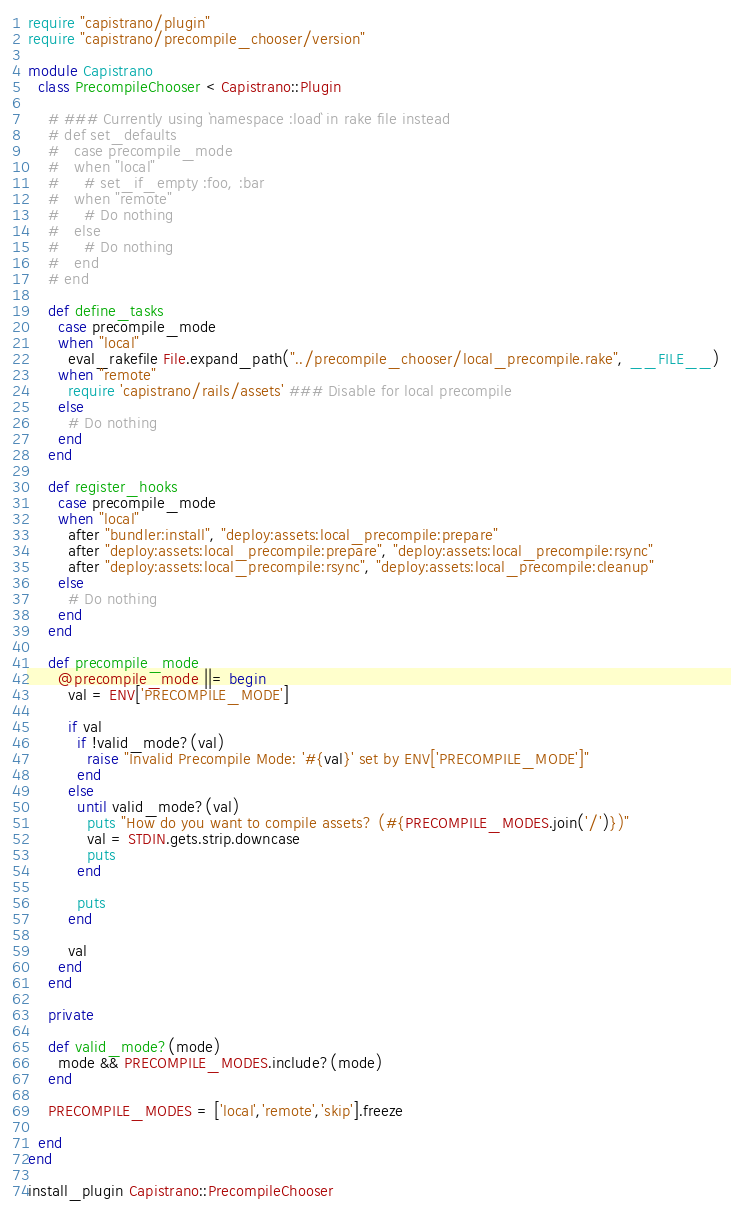Convert code to text. <code><loc_0><loc_0><loc_500><loc_500><_Ruby_>require "capistrano/plugin"
require "capistrano/precompile_chooser/version"

module Capistrano
  class PrecompileChooser < Capistrano::Plugin

    # ### Currently using `namespace :load` in rake file instead
    # def set_defaults
    #   case precompile_mode
    #   when "local"
    #     # set_if_empty :foo, :bar
    #   when "remote"
    #     # Do nothing
    #   else
    #     # Do nothing
    #   end
    # end

    def define_tasks
      case precompile_mode
      when "local"
        eval_rakefile File.expand_path("../precompile_chooser/local_precompile.rake", __FILE__)
      when "remote"
        require 'capistrano/rails/assets' ### Disable for local precompile
      else
        # Do nothing
      end
    end

    def register_hooks
      case precompile_mode
      when "local"
        after "bundler:install", "deploy:assets:local_precompile:prepare"
        after "deploy:assets:local_precompile:prepare", "deploy:assets:local_precompile:rsync"
        after "deploy:assets:local_precompile:rsync", "deploy:assets:local_precompile:cleanup"
      else
        # Do nothing
      end
    end

    def precompile_mode
      @precompile_mode ||= begin
        val = ENV['PRECOMPILE_MODE']

        if val
          if !valid_mode?(val)
            raise "Invalid Precompile Mode: '#{val}' set by ENV['PRECOMPILE_MODE']"
          end
        else
          until valid_mode?(val)
            puts "How do you want to compile assets? (#{PRECOMPILE_MODES.join('/')})"
            val = STDIN.gets.strip.downcase
            puts
          end

          puts
        end

        val
      end
    end

    private

    def valid_mode?(mode)
      mode && PRECOMPILE_MODES.include?(mode)
    end

    PRECOMPILE_MODES = ['local','remote','skip'].freeze

  end
end

install_plugin Capistrano::PrecompileChooser
</code> 